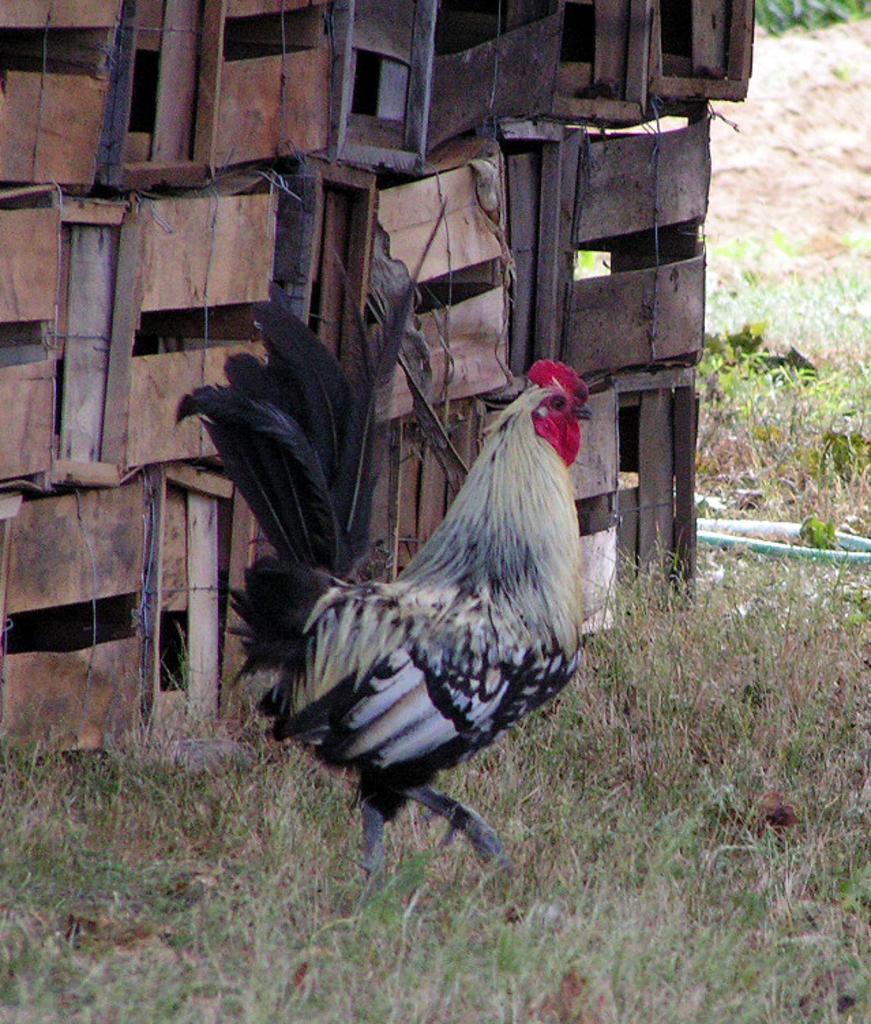Can you describe this image briefly? In this image in the center there is one hen, and in the background there are some wooden sticks. And at the bottom there is grass, and on the right side of the image there is some grass and plants and some object. 